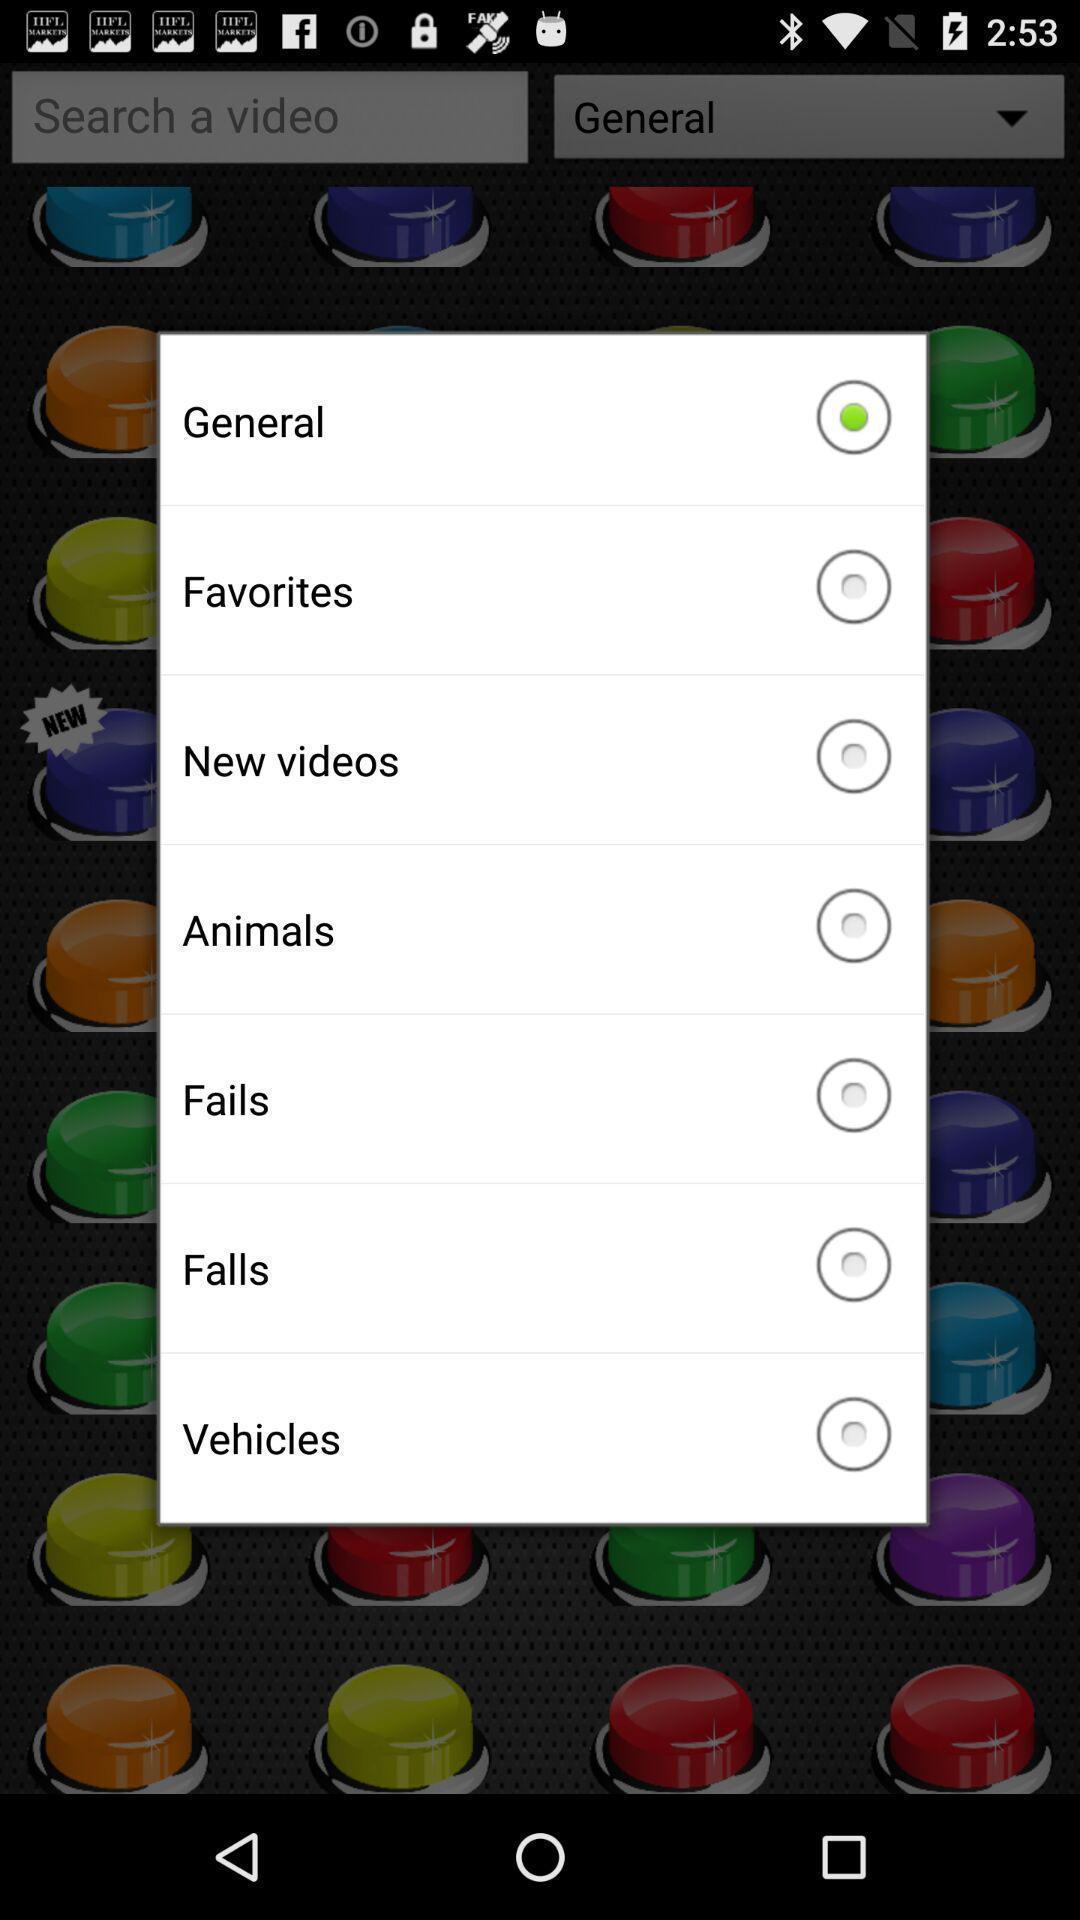Describe this image in words. Popup of list of types of videos to select. 